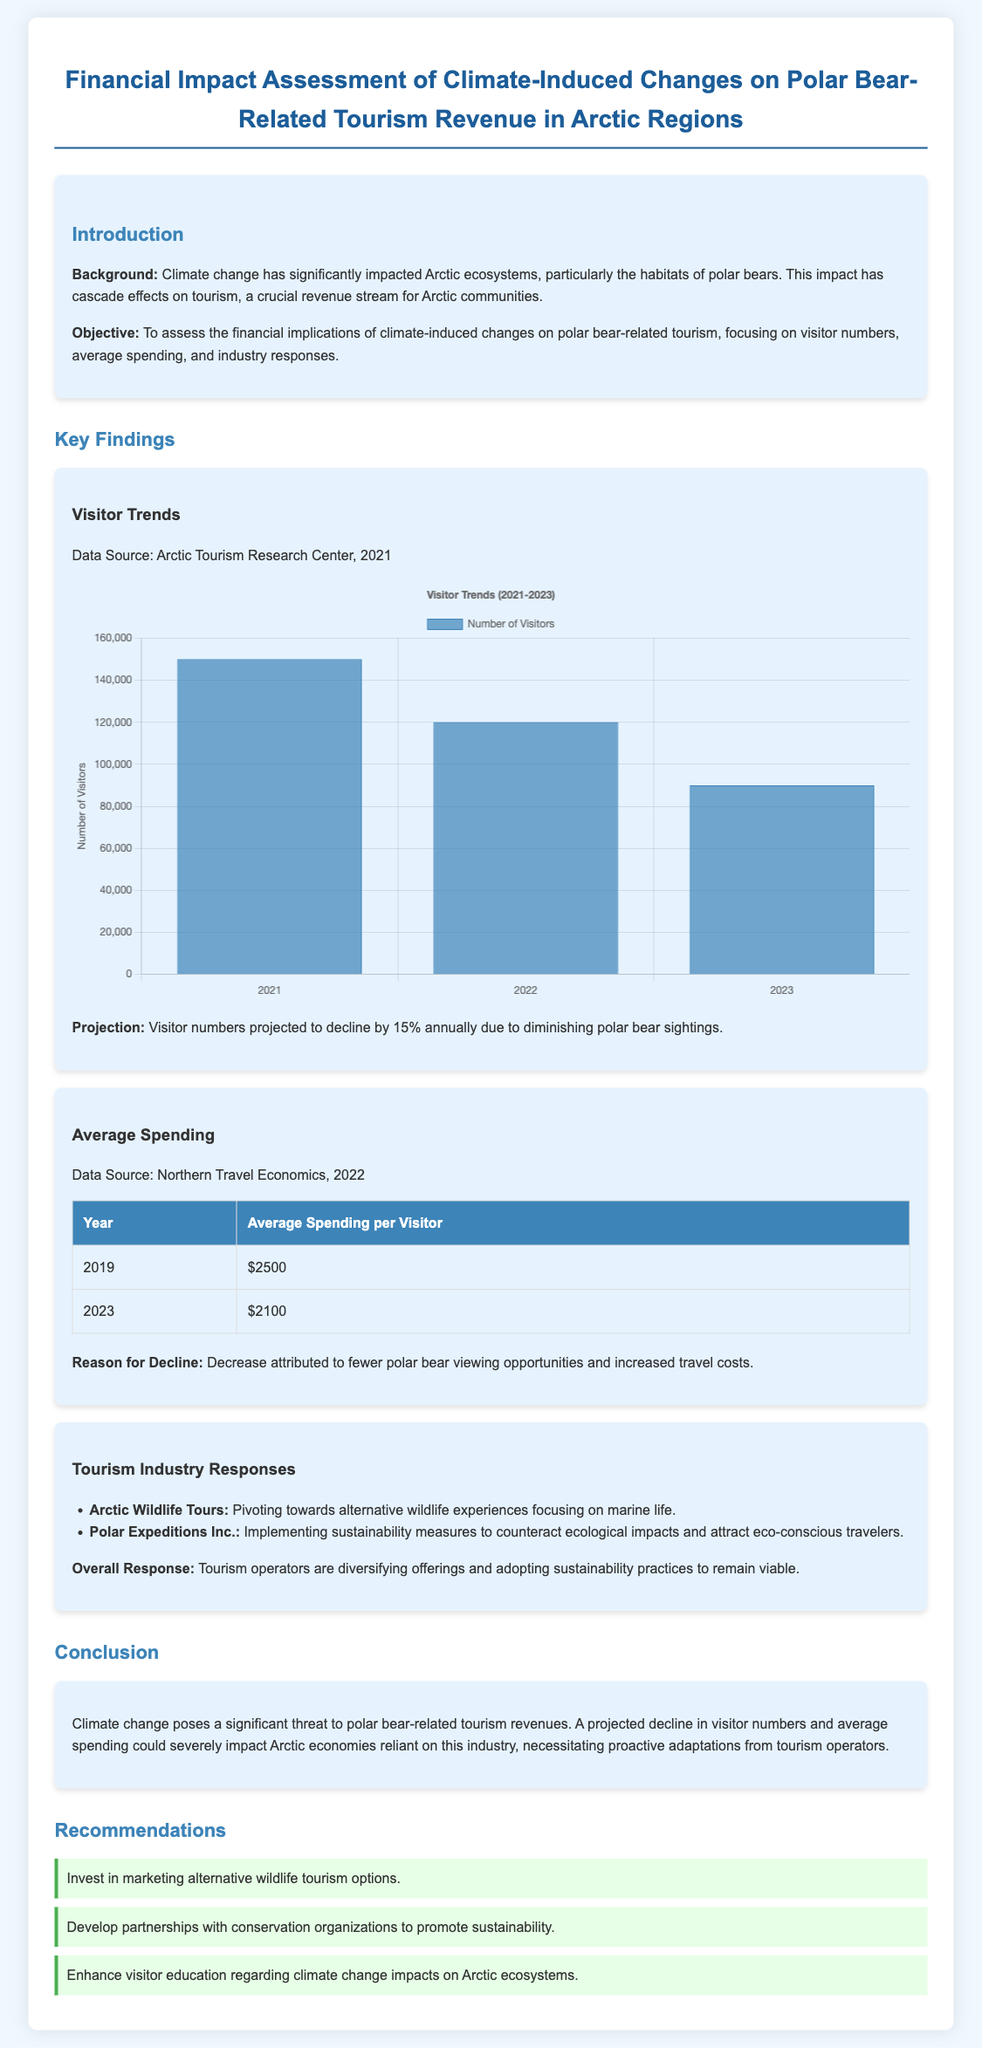What is the projected decline in visitor numbers? The document states that visitor numbers are projected to decline by 15% annually.
Answer: 15% What was the average spending per visitor in 2019? According to the table in the document, the average spending per visitor in 2019 was $2500.
Answer: $2500 What is the average spending per visitor in 2023? The document indicates that average spending per visitor in 2023 decreased to $2100.
Answer: $2100 How many visitors were recorded in 2023? The visitor chart shows that the number of visitors in 2023 was 90,000.
Answer: 90,000 Which company is implementing sustainability measures? The document names Polar Expeditions Inc. as the company implementing sustainability measures.
Answer: Polar Expeditions Inc What is the main reason for the decline in average spending? The document attributes the decline in average spending to fewer polar bear viewing opportunities and increased travel costs.
Answer: Fewer polar bear viewing opportunities and increased travel costs What does the report recommend regarding marketing? The report recommends investing in marketing alternative wildlife tourism options.
Answer: Marketing alternative wildlife tourism options In what year was the visitor data sourced? The document states that the visitor data was sourced from the Arctic Tourism Research Center in 2021.
Answer: 2021 